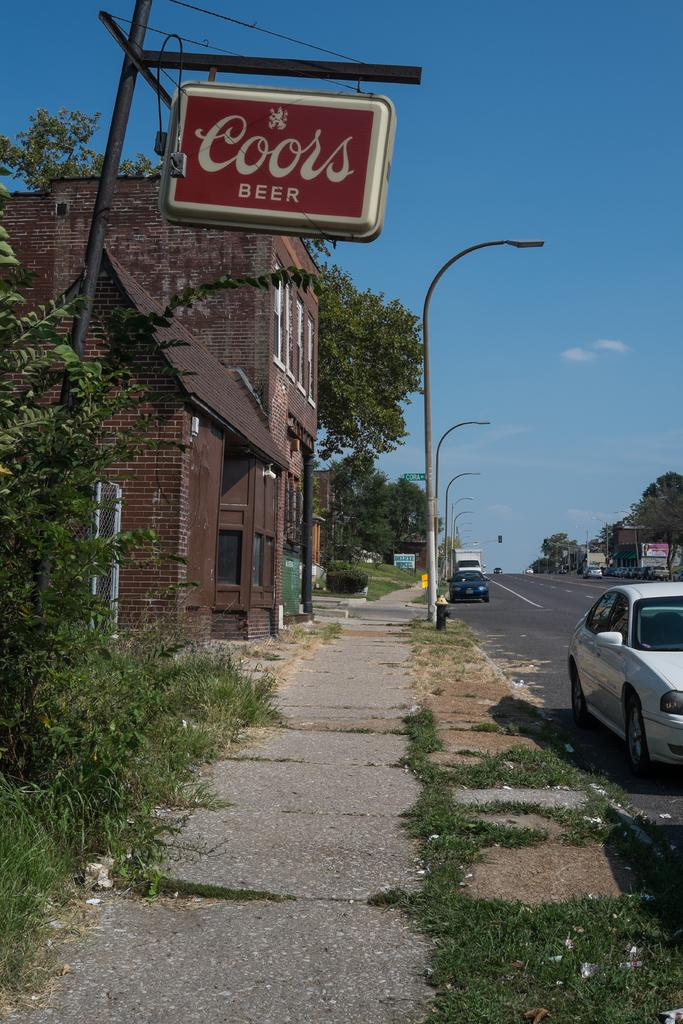What type of natural elements can be seen in the image? There are trees in the image. What type of artificial lighting is present in the image? There are street lamps in the image. What type of man-made structures are visible in the image? There are buildings in the image. What part of the natural environment is visible in the image? The sky is visible in the image. What type of vehicles can be seen in the image? There are cars in the image. What type of stamp can be seen on the flag in the image? There is no flag or stamp present in the image. How does the sleet affect the visibility of the buildings in the image? There is no sleet present in the image, so it does not affect the visibility of the buildings. 